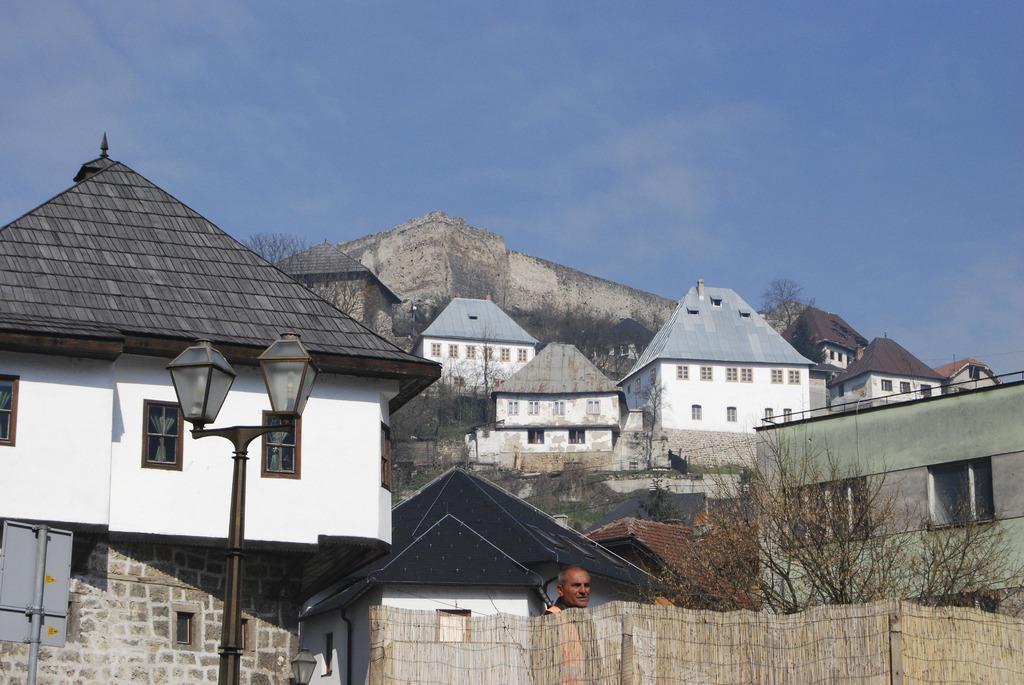Can you describe this image briefly? In this image we can see fort, buildings, trees, person, fencing, streetlight, sky and clouds. 